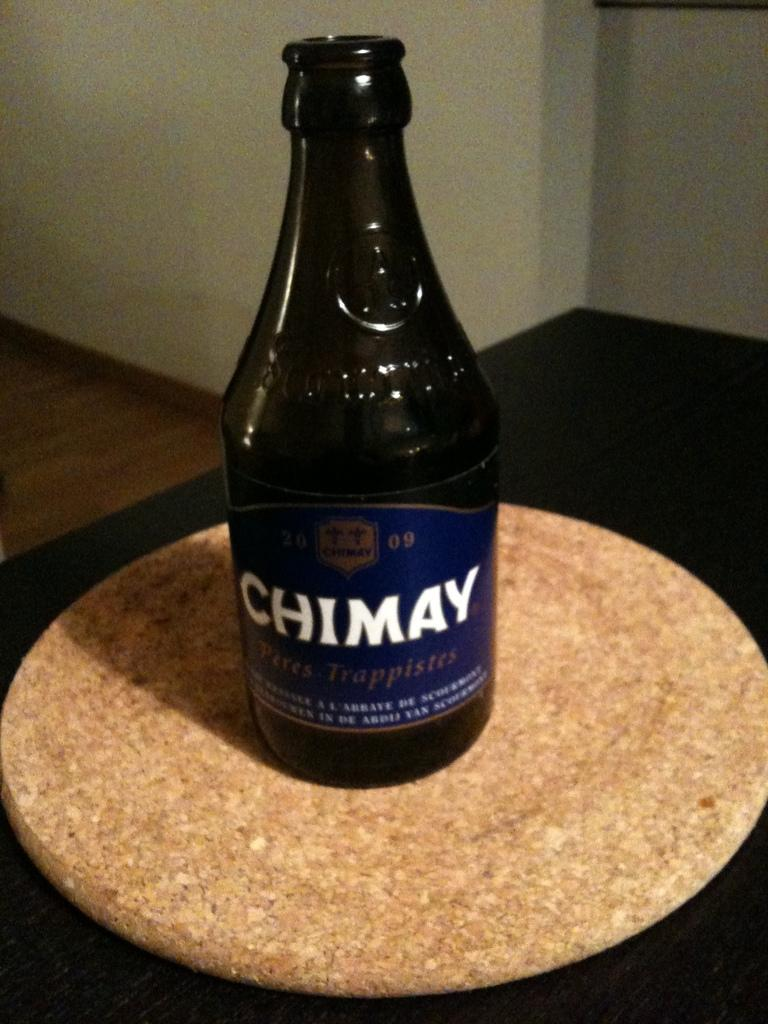Provide a one-sentence caption for the provided image. A bottle with a blue label of Chimay on top of round disk displayed on a table. 